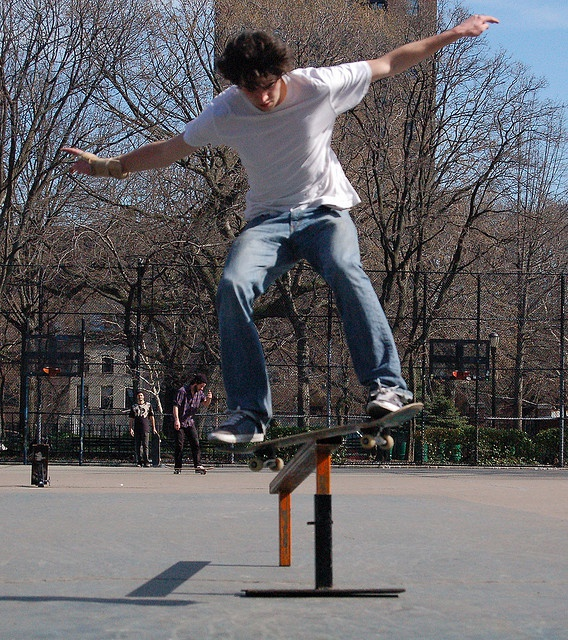Describe the objects in this image and their specific colors. I can see people in lightblue, black, gray, darkgray, and lightgray tones, skateboard in lightblue, black, and gray tones, people in lightblue, black, gray, maroon, and purple tones, people in lightblue, black, gray, maroon, and lightgray tones, and skateboard in lightblue, black, gray, and darkgray tones in this image. 